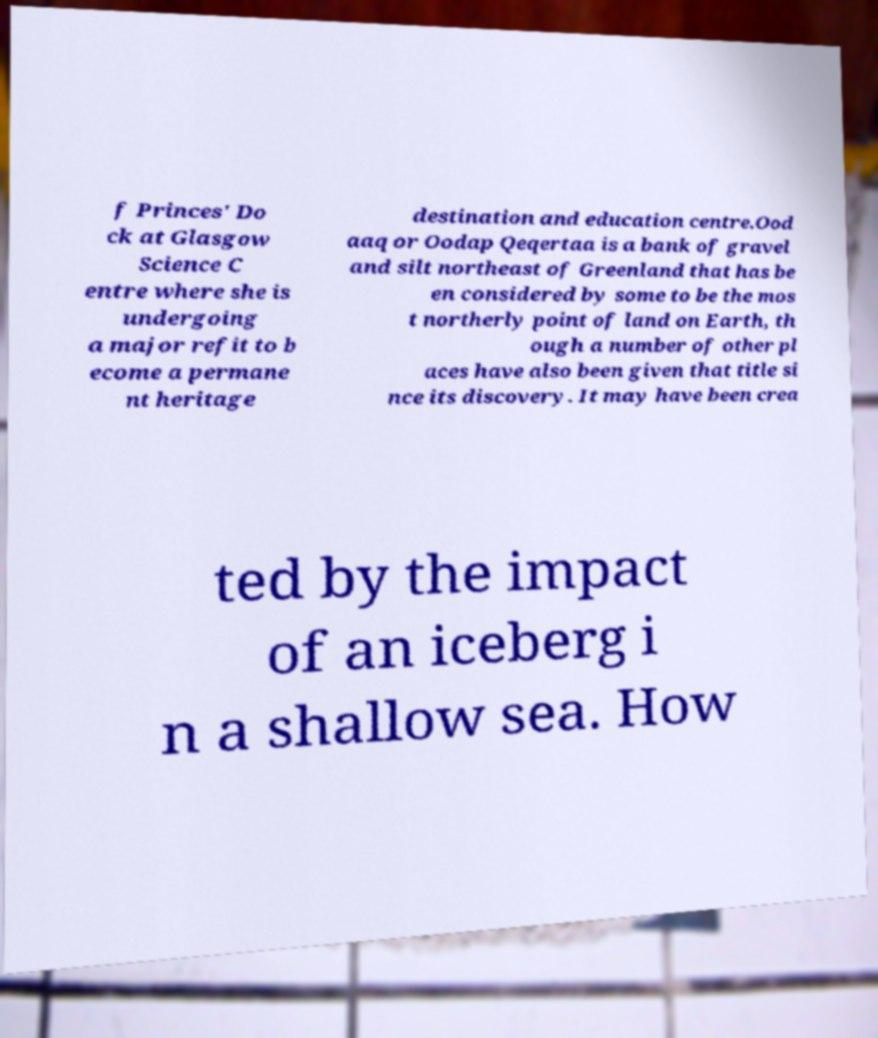Could you extract and type out the text from this image? f Princes' Do ck at Glasgow Science C entre where she is undergoing a major refit to b ecome a permane nt heritage destination and education centre.Ood aaq or Oodap Qeqertaa is a bank of gravel and silt northeast of Greenland that has be en considered by some to be the mos t northerly point of land on Earth, th ough a number of other pl aces have also been given that title si nce its discovery. It may have been crea ted by the impact of an iceberg i n a shallow sea. How 